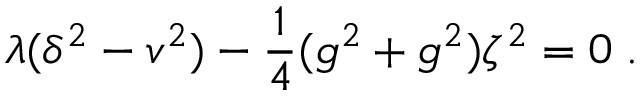<formula> <loc_0><loc_0><loc_500><loc_500>\lambda ( \delta ^ { 2 } - v ^ { 2 } ) - \frac { 1 } { 4 } ( g ^ { 2 } + g ^ { 2 } ) \zeta ^ { 2 } = 0 \, .</formula> 